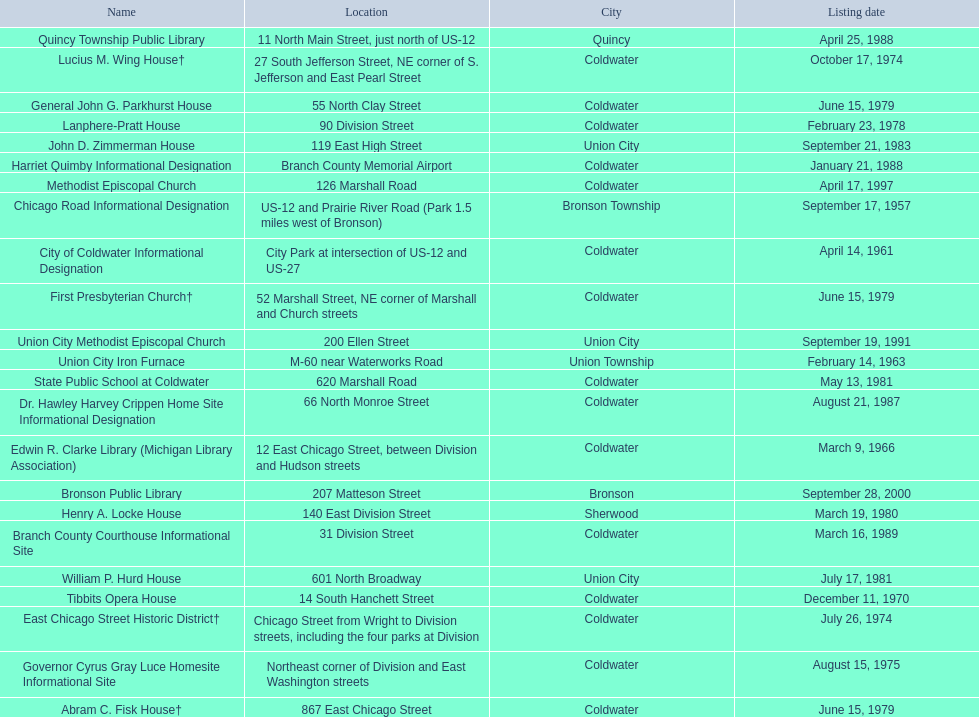Are there any listing dates that happened before 1960? September 17, 1957. Would you mind parsing the complete table? {'header': ['Name', 'Location', 'City', 'Listing date'], 'rows': [['Quincy Township Public Library', '11 North Main Street, just north of US-12', 'Quincy', 'April 25, 1988'], ['Lucius M. Wing House†', '27 South Jefferson Street, NE corner of S. Jefferson and East Pearl Street', 'Coldwater', 'October 17, 1974'], ['General John G. Parkhurst House', '55 North Clay Street', 'Coldwater', 'June 15, 1979'], ['Lanphere-Pratt House', '90 Division Street', 'Coldwater', 'February 23, 1978'], ['John D. Zimmerman House', '119 East High Street', 'Union City', 'September 21, 1983'], ['Harriet Quimby Informational Designation', 'Branch County Memorial Airport', 'Coldwater', 'January 21, 1988'], ['Methodist Episcopal Church', '126 Marshall Road', 'Coldwater', 'April 17, 1997'], ['Chicago Road Informational Designation', 'US-12 and Prairie River Road (Park 1.5 miles west of Bronson)', 'Bronson Township', 'September 17, 1957'], ['City of Coldwater Informational Designation', 'City Park at intersection of US-12 and US-27', 'Coldwater', 'April 14, 1961'], ['First Presbyterian Church†', '52 Marshall Street, NE corner of Marshall and Church streets', 'Coldwater', 'June 15, 1979'], ['Union City Methodist Episcopal Church', '200 Ellen Street', 'Union City', 'September 19, 1991'], ['Union City Iron Furnace', 'M-60 near Waterworks Road', 'Union Township', 'February 14, 1963'], ['State Public School at Coldwater', '620 Marshall Road', 'Coldwater', 'May 13, 1981'], ['Dr. Hawley Harvey Crippen Home Site Informational Designation', '66 North Monroe Street', 'Coldwater', 'August 21, 1987'], ['Edwin R. Clarke Library (Michigan Library Association)', '12 East Chicago Street, between Division and Hudson streets', 'Coldwater', 'March 9, 1966'], ['Bronson Public Library', '207 Matteson Street', 'Bronson', 'September 28, 2000'], ['Henry A. Locke House', '140 East Division Street', 'Sherwood', 'March 19, 1980'], ['Branch County Courthouse Informational Site', '31 Division Street', 'Coldwater', 'March 16, 1989'], ['William P. Hurd House', '601 North Broadway', 'Union City', 'July 17, 1981'], ['Tibbits Opera House', '14 South Hanchett Street', 'Coldwater', 'December 11, 1970'], ['East Chicago Street Historic District†', 'Chicago Street from Wright to Division streets, including the four parks at Division', 'Coldwater', 'July 26, 1974'], ['Governor Cyrus Gray Luce Homesite Informational Site', 'Northeast corner of Division and East Washington streets', 'Coldwater', 'August 15, 1975'], ['Abram C. Fisk House†', '867 East Chicago Street', 'Coldwater', 'June 15, 1979']]} What is the name of the site that was listed before 1960? Chicago Road Informational Designation. 